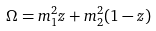<formula> <loc_0><loc_0><loc_500><loc_500>\Omega = m _ { 1 } ^ { 2 } z + m _ { 2 } ^ { 2 } ( 1 - z )</formula> 